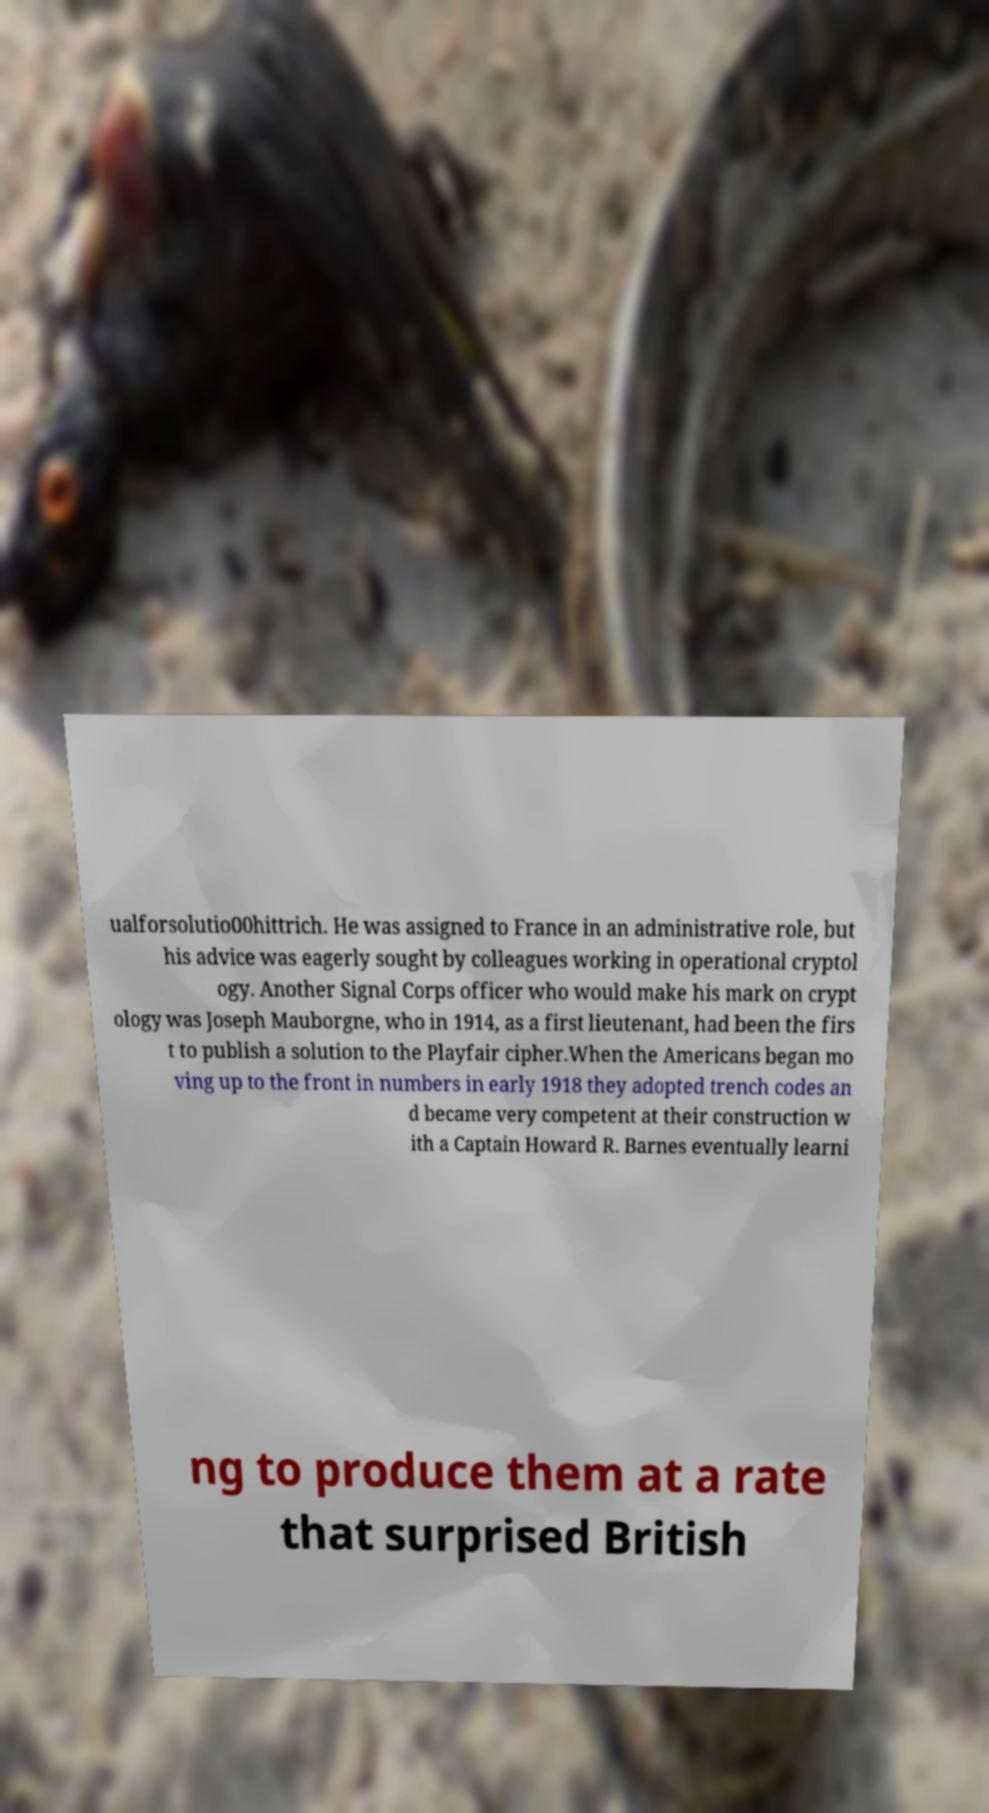Could you assist in decoding the text presented in this image and type it out clearly? ualforsolutio00hittrich. He was assigned to France in an administrative role, but his advice was eagerly sought by colleagues working in operational cryptol ogy. Another Signal Corps officer who would make his mark on crypt ology was Joseph Mauborgne, who in 1914, as a first lieutenant, had been the firs t to publish a solution to the Playfair cipher.When the Americans began mo ving up to the front in numbers in early 1918 they adopted trench codes an d became very competent at their construction w ith a Captain Howard R. Barnes eventually learni ng to produce them at a rate that surprised British 